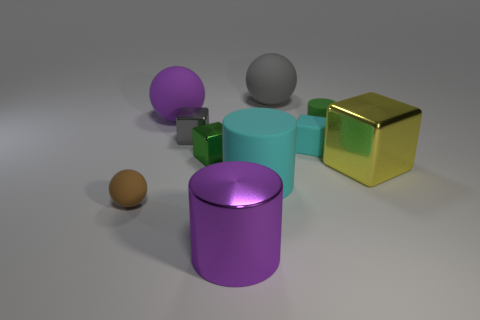What is the shape of the purple matte object?
Offer a terse response. Sphere. What shape is the object that is both behind the large yellow metal thing and on the right side of the small cyan block?
Your answer should be very brief. Cylinder. There is a big cylinder that is made of the same material as the gray cube; what color is it?
Keep it short and to the point. Purple. There is a large purple object in front of the large purple thing that is behind the object that is right of the green matte thing; what is its shape?
Keep it short and to the point. Cylinder. What size is the green shiny cube?
Your answer should be compact. Small. There is a big yellow object that is made of the same material as the gray cube; what is its shape?
Provide a short and direct response. Cube. Is the number of big purple shiny objects that are behind the big metal cube less than the number of small gray metal cubes?
Give a very brief answer. Yes. There is a ball that is in front of the small gray metal object; what color is it?
Your response must be concise. Brown. There is a small object that is the same color as the big rubber cylinder; what is it made of?
Provide a succinct answer. Rubber. Are there any other tiny brown objects that have the same shape as the brown object?
Make the answer very short. No. 